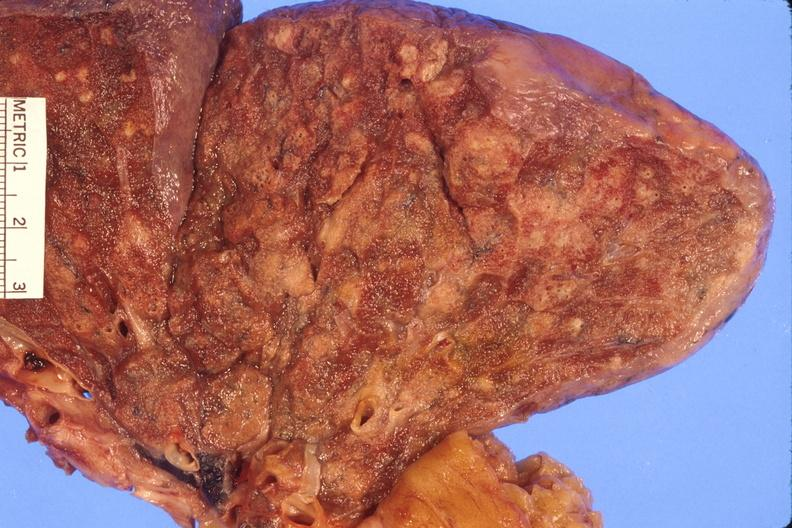what does this image show?
Answer the question using a single word or phrase. Lung 